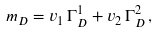Convert formula to latex. <formula><loc_0><loc_0><loc_500><loc_500>m _ { D } = v _ { 1 } \, \Gamma ^ { 1 } _ { D } + v _ { 2 } \, \Gamma ^ { 2 } _ { D } \, ,</formula> 